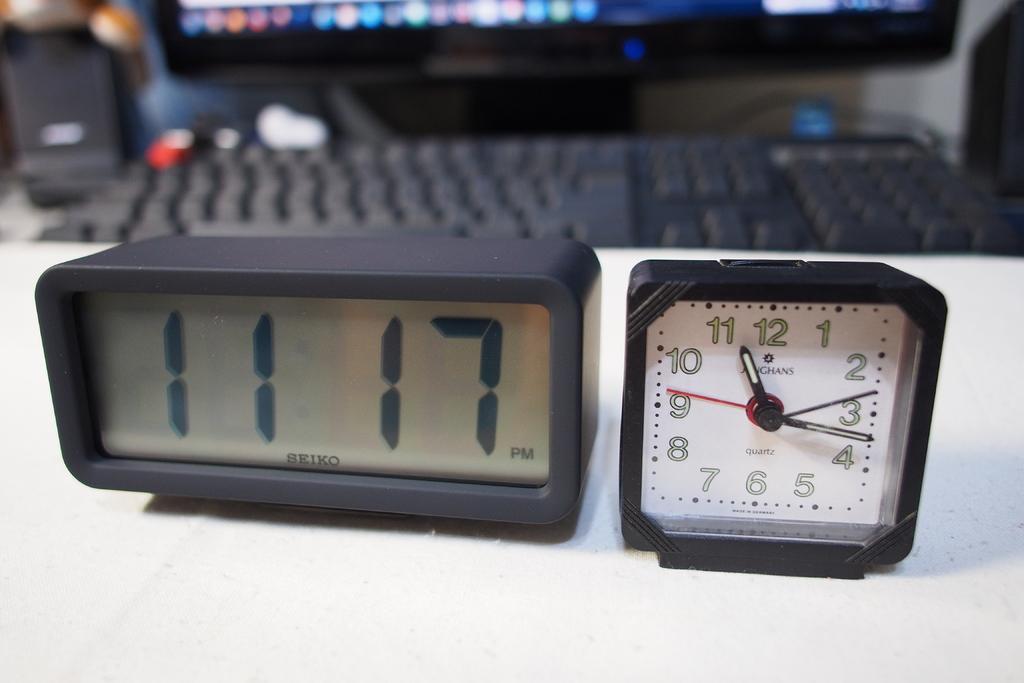Describe this image in one or two sentences. In the picture I can see digital clock and analog clock and in the background there is keyboard, monitor and sound box. 